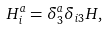<formula> <loc_0><loc_0><loc_500><loc_500>H ^ { a } _ { i } = \delta ^ { a } _ { 3 } \delta _ { i 3 } H ,</formula> 